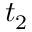<formula> <loc_0><loc_0><loc_500><loc_500>t _ { 2 }</formula> 